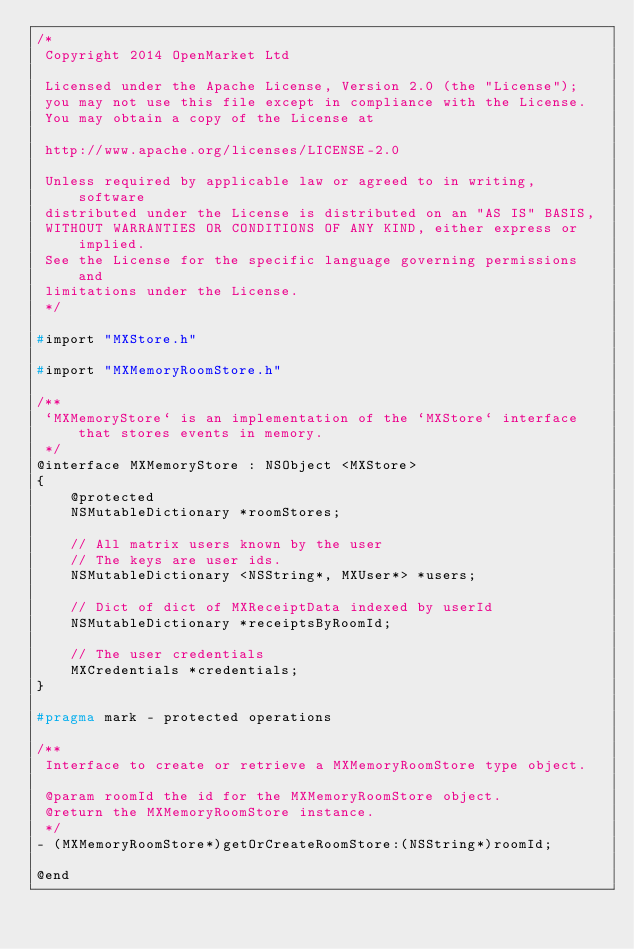Convert code to text. <code><loc_0><loc_0><loc_500><loc_500><_C_>/*
 Copyright 2014 OpenMarket Ltd

 Licensed under the Apache License, Version 2.0 (the "License");
 you may not use this file except in compliance with the License.
 You may obtain a copy of the License at

 http://www.apache.org/licenses/LICENSE-2.0

 Unless required by applicable law or agreed to in writing, software
 distributed under the License is distributed on an "AS IS" BASIS,
 WITHOUT WARRANTIES OR CONDITIONS OF ANY KIND, either express or implied.
 See the License for the specific language governing permissions and
 limitations under the License.
 */

#import "MXStore.h"

#import "MXMemoryRoomStore.h"

/**
 `MXMemoryStore` is an implementation of the `MXStore` interface that stores events in memory.
 */
@interface MXMemoryStore : NSObject <MXStore>
{
    @protected
    NSMutableDictionary *roomStores;

    // All matrix users known by the user
    // The keys are user ids.
    NSMutableDictionary <NSString*, MXUser*> *users;

    // Dict of dict of MXReceiptData indexed by userId
    NSMutableDictionary *receiptsByRoomId;

    // The user credentials
    MXCredentials *credentials;
}

#pragma mark - protected operations

/**
 Interface to create or retrieve a MXMemoryRoomStore type object.
 
 @param roomId the id for the MXMemoryRoomStore object.
 @return the MXMemoryRoomStore instance.
 */
- (MXMemoryRoomStore*)getOrCreateRoomStore:(NSString*)roomId;

@end
</code> 